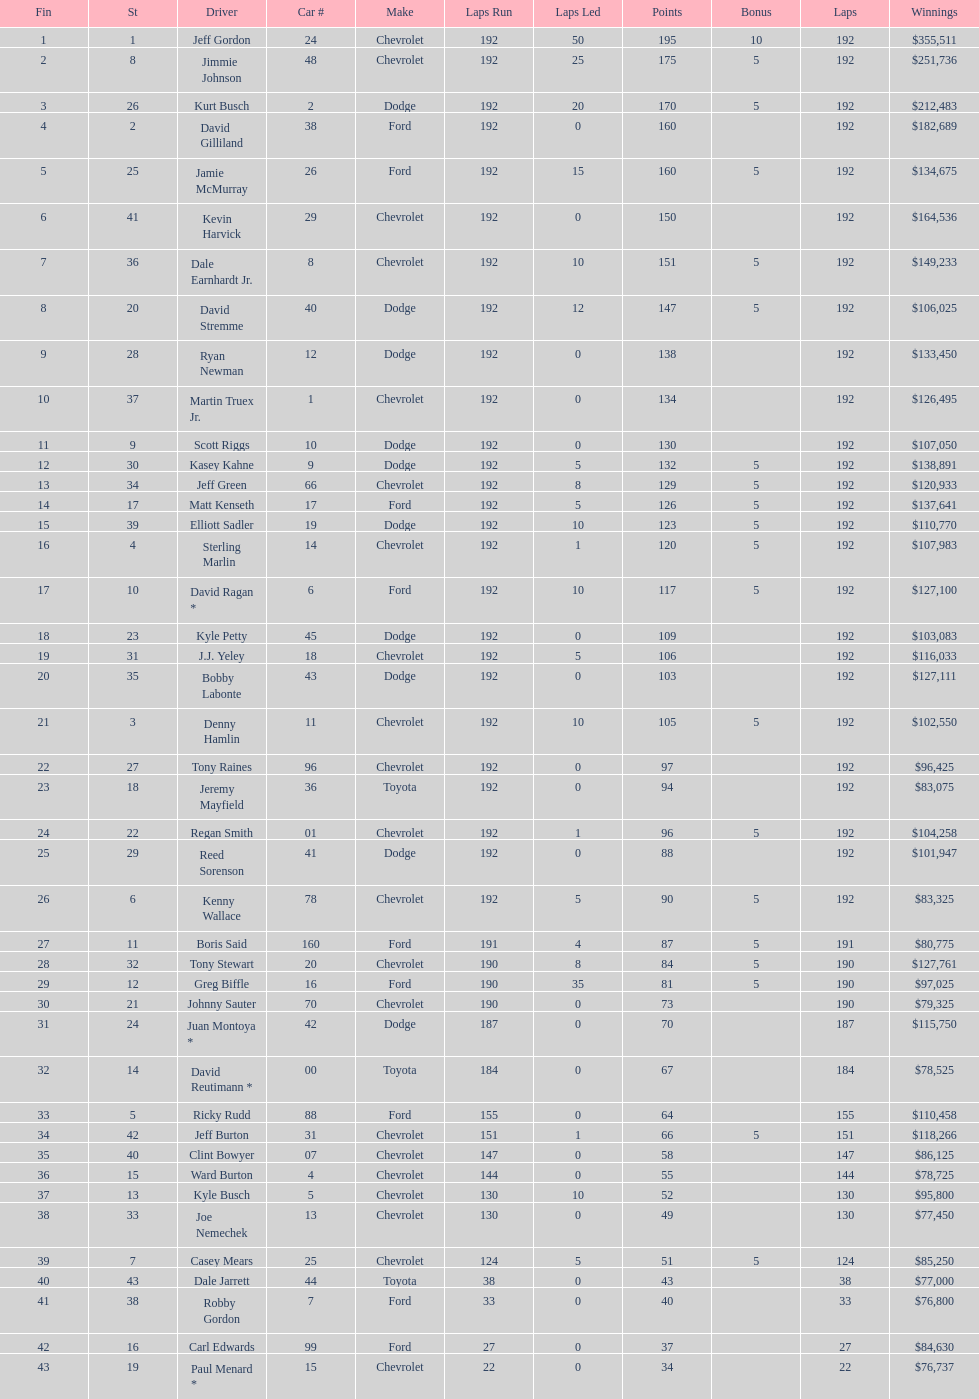Would you mind parsing the complete table? {'header': ['Fin', 'St', 'Driver', 'Car #', 'Make', 'Laps Run', 'Laps Led', 'Points', 'Bonus', 'Laps', 'Winnings'], 'rows': [['1', '1', 'Jeff Gordon', '24', 'Chevrolet', '192', '50', '195', '10', '192', '$355,511'], ['2', '8', 'Jimmie Johnson', '48', 'Chevrolet', '192', '25', '175', '5', '192', '$251,736'], ['3', '26', 'Kurt Busch', '2', 'Dodge', '192', '20', '170', '5', '192', '$212,483'], ['4', '2', 'David Gilliland', '38', 'Ford', '192', '0', '160', '', '192', '$182,689'], ['5', '25', 'Jamie McMurray', '26', 'Ford', '192', '15', '160', '5', '192', '$134,675'], ['6', '41', 'Kevin Harvick', '29', 'Chevrolet', '192', '0', '150', '', '192', '$164,536'], ['7', '36', 'Dale Earnhardt Jr.', '8', 'Chevrolet', '192', '10', '151', '5', '192', '$149,233'], ['8', '20', 'David Stremme', '40', 'Dodge', '192', '12', '147', '5', '192', '$106,025'], ['9', '28', 'Ryan Newman', '12', 'Dodge', '192', '0', '138', '', '192', '$133,450'], ['10', '37', 'Martin Truex Jr.', '1', 'Chevrolet', '192', '0', '134', '', '192', '$126,495'], ['11', '9', 'Scott Riggs', '10', 'Dodge', '192', '0', '130', '', '192', '$107,050'], ['12', '30', 'Kasey Kahne', '9', 'Dodge', '192', '5', '132', '5', '192', '$138,891'], ['13', '34', 'Jeff Green', '66', 'Chevrolet', '192', '8', '129', '5', '192', '$120,933'], ['14', '17', 'Matt Kenseth', '17', 'Ford', '192', '5', '126', '5', '192', '$137,641'], ['15', '39', 'Elliott Sadler', '19', 'Dodge', '192', '10', '123', '5', '192', '$110,770'], ['16', '4', 'Sterling Marlin', '14', 'Chevrolet', '192', '1', '120', '5', '192', '$107,983'], ['17', '10', 'David Ragan *', '6', 'Ford', '192', '10', '117', '5', '192', '$127,100'], ['18', '23', 'Kyle Petty', '45', 'Dodge', '192', '0', '109', '', '192', '$103,083'], ['19', '31', 'J.J. Yeley', '18', 'Chevrolet', '192', '5', '106', '', '192', '$116,033'], ['20', '35', 'Bobby Labonte', '43', 'Dodge', '192', '0', '103', '', '192', '$127,111'], ['21', '3', 'Denny Hamlin', '11', 'Chevrolet', '192', '10', '105', '5', '192', '$102,550'], ['22', '27', 'Tony Raines', '96', 'Chevrolet', '192', '0', '97', '', '192', '$96,425'], ['23', '18', 'Jeremy Mayfield', '36', 'Toyota', '192', '0', '94', '', '192', '$83,075'], ['24', '22', 'Regan Smith', '01', 'Chevrolet', '192', '1', '96', '5', '192', '$104,258'], ['25', '29', 'Reed Sorenson', '41', 'Dodge', '192', '0', '88', '', '192', '$101,947'], ['26', '6', 'Kenny Wallace', '78', 'Chevrolet', '192', '5', '90', '5', '192', '$83,325'], ['27', '11', 'Boris Said', '160', 'Ford', '191', '4', '87', '5', '191', '$80,775'], ['28', '32', 'Tony Stewart', '20', 'Chevrolet', '190', '8', '84', '5', '190', '$127,761'], ['29', '12', 'Greg Biffle', '16', 'Ford', '190', '35', '81', '5', '190', '$97,025'], ['30', '21', 'Johnny Sauter', '70', 'Chevrolet', '190', '0', '73', '', '190', '$79,325'], ['31', '24', 'Juan Montoya *', '42', 'Dodge', '187', '0', '70', '', '187', '$115,750'], ['32', '14', 'David Reutimann *', '00', 'Toyota', '184', '0', '67', '', '184', '$78,525'], ['33', '5', 'Ricky Rudd', '88', 'Ford', '155', '0', '64', '', '155', '$110,458'], ['34', '42', 'Jeff Burton', '31', 'Chevrolet', '151', '1', '66', '5', '151', '$118,266'], ['35', '40', 'Clint Bowyer', '07', 'Chevrolet', '147', '0', '58', '', '147', '$86,125'], ['36', '15', 'Ward Burton', '4', 'Chevrolet', '144', '0', '55', '', '144', '$78,725'], ['37', '13', 'Kyle Busch', '5', 'Chevrolet', '130', '10', '52', '', '130', '$95,800'], ['38', '33', 'Joe Nemechek', '13', 'Chevrolet', '130', '0', '49', '', '130', '$77,450'], ['39', '7', 'Casey Mears', '25', 'Chevrolet', '124', '5', '51', '5', '124', '$85,250'], ['40', '43', 'Dale Jarrett', '44', 'Toyota', '38', '0', '43', '', '38', '$77,000'], ['41', '38', 'Robby Gordon', '7', 'Ford', '33', '0', '40', '', '33', '$76,800'], ['42', '16', 'Carl Edwards', '99', 'Ford', '27', '0', '37', '', '27', '$84,630'], ['43', '19', 'Paul Menard *', '15', 'Chevrolet', '22', '0', '34', '', '22', '$76,737']]} What was the make of both jeff gordon's and jimmie johnson's race car? Chevrolet. 